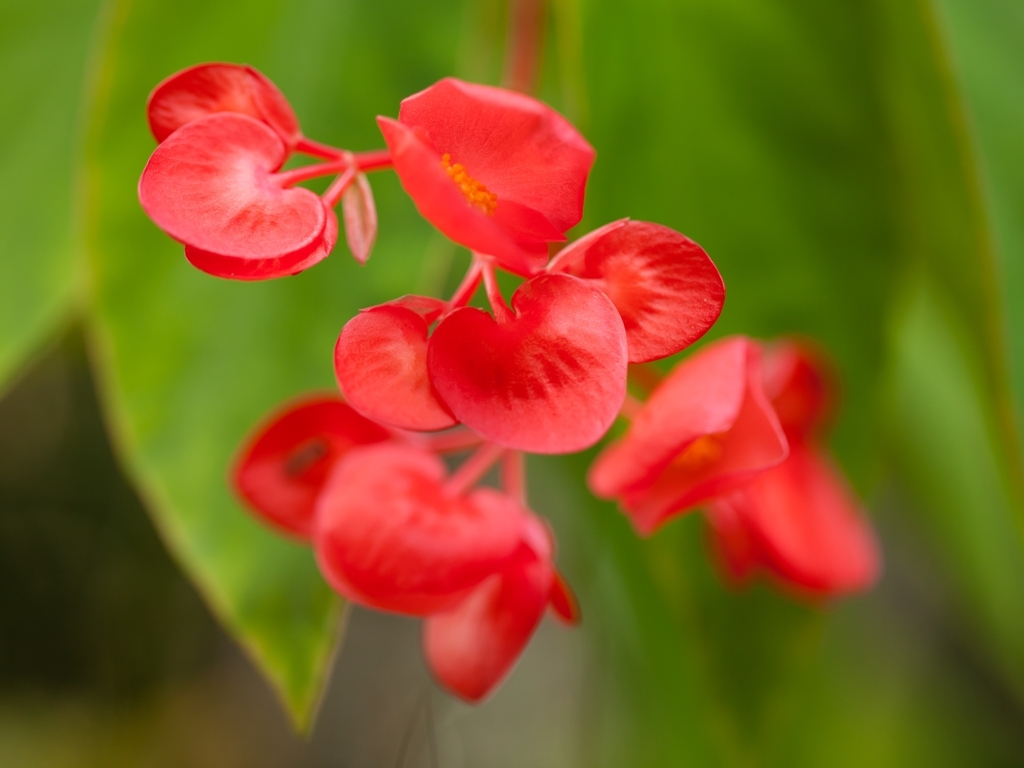What is the clarity of this photo?
A. Acceptable
B. Poor
C. Excellent
D. Average
Answer with the option's letter from the given choices directly. The clarity of the photo can be classified as 'C. Excellent.' The subject, which appears to be a bright red flower with heart-shaped petals, is in sharp focus, with the background appropriately blurred. This selective focus highlights the flower's vibrant colors and delicate textures, contributing to the overall high quality of the image. 